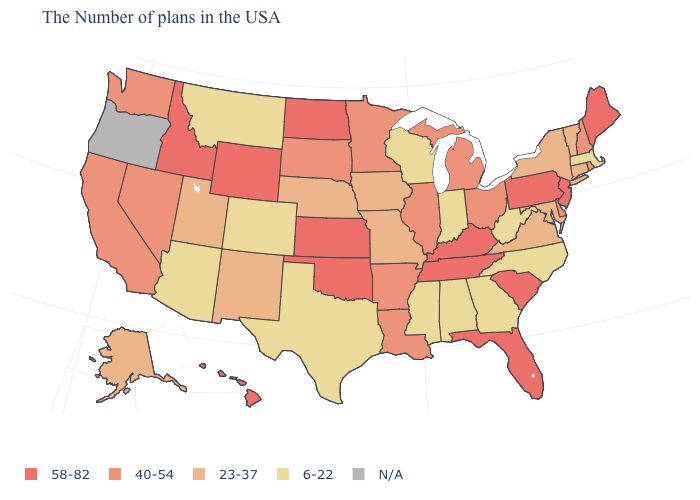Name the states that have a value in the range 23-37?
Write a very short answer. Vermont, Connecticut, New York, Maryland, Virginia, Missouri, Iowa, Nebraska, New Mexico, Utah, Alaska. What is the value of Delaware?
Answer briefly. 40-54. Which states have the lowest value in the Northeast?
Write a very short answer. Massachusetts. What is the value of Pennsylvania?
Be succinct. 58-82. Name the states that have a value in the range 6-22?
Write a very short answer. Massachusetts, North Carolina, West Virginia, Georgia, Indiana, Alabama, Wisconsin, Mississippi, Texas, Colorado, Montana, Arizona. Is the legend a continuous bar?
Give a very brief answer. No. What is the value of Iowa?
Write a very short answer. 23-37. Does Missouri have the highest value in the MidWest?
Be succinct. No. What is the lowest value in the USA?
Keep it brief. 6-22. Is the legend a continuous bar?
Give a very brief answer. No. Which states have the lowest value in the USA?
Concise answer only. Massachusetts, North Carolina, West Virginia, Georgia, Indiana, Alabama, Wisconsin, Mississippi, Texas, Colorado, Montana, Arizona. What is the highest value in states that border Nebraska?
Keep it brief. 58-82. What is the highest value in the USA?
Answer briefly. 58-82. Among the states that border Maryland , does Pennsylvania have the highest value?
Short answer required. Yes. What is the lowest value in the USA?
Answer briefly. 6-22. 